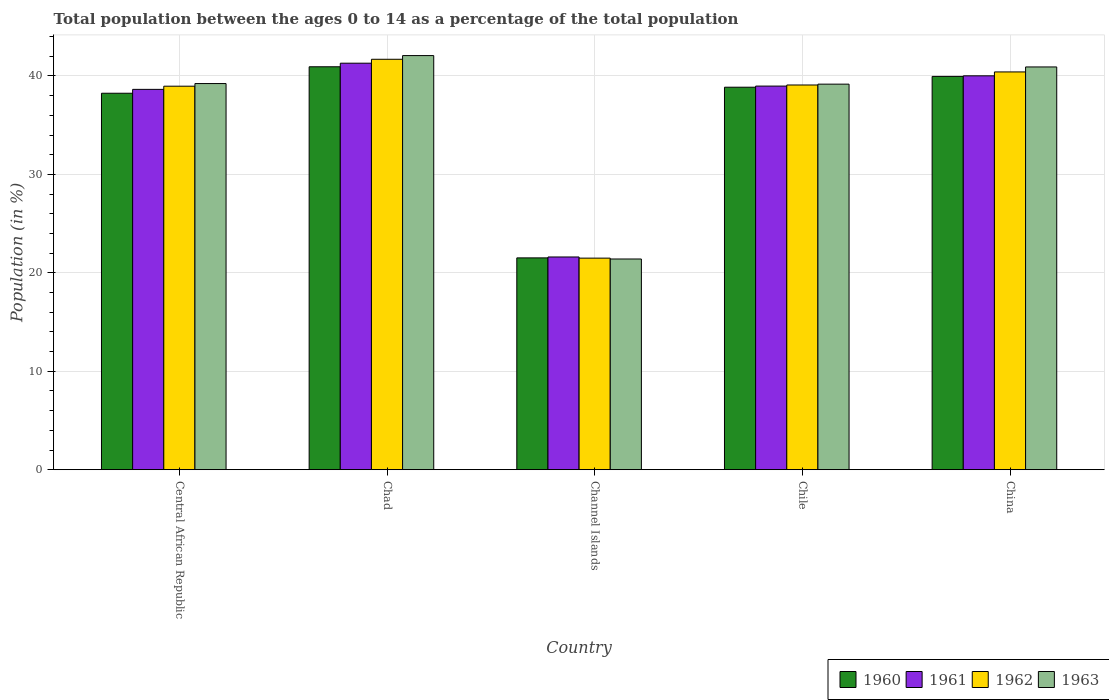Are the number of bars per tick equal to the number of legend labels?
Ensure brevity in your answer.  Yes. Are the number of bars on each tick of the X-axis equal?
Offer a terse response. Yes. How many bars are there on the 1st tick from the right?
Offer a very short reply. 4. What is the label of the 5th group of bars from the left?
Make the answer very short. China. What is the percentage of the population ages 0 to 14 in 1960 in Chile?
Keep it short and to the point. 38.86. Across all countries, what is the maximum percentage of the population ages 0 to 14 in 1962?
Ensure brevity in your answer.  41.7. Across all countries, what is the minimum percentage of the population ages 0 to 14 in 1962?
Your answer should be very brief. 21.49. In which country was the percentage of the population ages 0 to 14 in 1963 maximum?
Your answer should be compact. Chad. In which country was the percentage of the population ages 0 to 14 in 1963 minimum?
Your answer should be very brief. Channel Islands. What is the total percentage of the population ages 0 to 14 in 1961 in the graph?
Your answer should be compact. 180.53. What is the difference between the percentage of the population ages 0 to 14 in 1962 in Channel Islands and that in China?
Make the answer very short. -18.92. What is the difference between the percentage of the population ages 0 to 14 in 1962 in China and the percentage of the population ages 0 to 14 in 1963 in Channel Islands?
Ensure brevity in your answer.  19. What is the average percentage of the population ages 0 to 14 in 1962 per country?
Provide a short and direct response. 36.33. What is the difference between the percentage of the population ages 0 to 14 of/in 1963 and percentage of the population ages 0 to 14 of/in 1962 in Central African Republic?
Your answer should be very brief. 0.27. What is the ratio of the percentage of the population ages 0 to 14 in 1962 in Central African Republic to that in Chad?
Provide a succinct answer. 0.93. Is the difference between the percentage of the population ages 0 to 14 in 1963 in Chad and China greater than the difference between the percentage of the population ages 0 to 14 in 1962 in Chad and China?
Make the answer very short. No. What is the difference between the highest and the second highest percentage of the population ages 0 to 14 in 1960?
Provide a succinct answer. 2.08. What is the difference between the highest and the lowest percentage of the population ages 0 to 14 in 1960?
Your response must be concise. 19.41. Is the sum of the percentage of the population ages 0 to 14 in 1962 in Chad and Channel Islands greater than the maximum percentage of the population ages 0 to 14 in 1961 across all countries?
Offer a terse response. Yes. Is it the case that in every country, the sum of the percentage of the population ages 0 to 14 in 1962 and percentage of the population ages 0 to 14 in 1963 is greater than the percentage of the population ages 0 to 14 in 1961?
Your response must be concise. Yes. How many bars are there?
Offer a terse response. 20. Are all the bars in the graph horizontal?
Ensure brevity in your answer.  No. How many countries are there in the graph?
Your answer should be very brief. 5. What is the difference between two consecutive major ticks on the Y-axis?
Keep it short and to the point. 10. Does the graph contain grids?
Your answer should be compact. Yes. How are the legend labels stacked?
Offer a terse response. Horizontal. What is the title of the graph?
Your answer should be compact. Total population between the ages 0 to 14 as a percentage of the total population. Does "2008" appear as one of the legend labels in the graph?
Give a very brief answer. No. What is the label or title of the Y-axis?
Provide a short and direct response. Population (in %). What is the Population (in %) in 1960 in Central African Republic?
Your response must be concise. 38.24. What is the Population (in %) of 1961 in Central African Republic?
Your response must be concise. 38.64. What is the Population (in %) in 1962 in Central African Republic?
Offer a very short reply. 38.96. What is the Population (in %) in 1963 in Central African Republic?
Make the answer very short. 39.23. What is the Population (in %) of 1960 in Chad?
Offer a terse response. 40.93. What is the Population (in %) of 1961 in Chad?
Make the answer very short. 41.3. What is the Population (in %) of 1962 in Chad?
Make the answer very short. 41.7. What is the Population (in %) of 1963 in Chad?
Offer a very short reply. 42.07. What is the Population (in %) of 1960 in Channel Islands?
Keep it short and to the point. 21.52. What is the Population (in %) of 1961 in Channel Islands?
Provide a short and direct response. 21.61. What is the Population (in %) of 1962 in Channel Islands?
Ensure brevity in your answer.  21.49. What is the Population (in %) of 1963 in Channel Islands?
Provide a short and direct response. 21.41. What is the Population (in %) of 1960 in Chile?
Offer a very short reply. 38.86. What is the Population (in %) of 1961 in Chile?
Give a very brief answer. 38.97. What is the Population (in %) in 1962 in Chile?
Your answer should be very brief. 39.08. What is the Population (in %) in 1963 in Chile?
Your answer should be very brief. 39.17. What is the Population (in %) of 1960 in China?
Give a very brief answer. 39.96. What is the Population (in %) in 1961 in China?
Offer a very short reply. 40.01. What is the Population (in %) of 1962 in China?
Your response must be concise. 40.41. What is the Population (in %) of 1963 in China?
Your response must be concise. 40.92. Across all countries, what is the maximum Population (in %) of 1960?
Offer a terse response. 40.93. Across all countries, what is the maximum Population (in %) of 1961?
Provide a short and direct response. 41.3. Across all countries, what is the maximum Population (in %) in 1962?
Provide a short and direct response. 41.7. Across all countries, what is the maximum Population (in %) in 1963?
Your response must be concise. 42.07. Across all countries, what is the minimum Population (in %) of 1960?
Offer a very short reply. 21.52. Across all countries, what is the minimum Population (in %) of 1961?
Give a very brief answer. 21.61. Across all countries, what is the minimum Population (in %) of 1962?
Make the answer very short. 21.49. Across all countries, what is the minimum Population (in %) in 1963?
Provide a succinct answer. 21.41. What is the total Population (in %) in 1960 in the graph?
Your answer should be compact. 179.51. What is the total Population (in %) in 1961 in the graph?
Offer a very short reply. 180.53. What is the total Population (in %) in 1962 in the graph?
Offer a very short reply. 181.64. What is the total Population (in %) of 1963 in the graph?
Ensure brevity in your answer.  182.79. What is the difference between the Population (in %) of 1960 in Central African Republic and that in Chad?
Provide a succinct answer. -2.69. What is the difference between the Population (in %) of 1961 in Central African Republic and that in Chad?
Offer a very short reply. -2.66. What is the difference between the Population (in %) of 1962 in Central African Republic and that in Chad?
Provide a succinct answer. -2.73. What is the difference between the Population (in %) of 1963 in Central African Republic and that in Chad?
Give a very brief answer. -2.84. What is the difference between the Population (in %) of 1960 in Central African Republic and that in Channel Islands?
Offer a terse response. 16.73. What is the difference between the Population (in %) of 1961 in Central African Republic and that in Channel Islands?
Offer a very short reply. 17.03. What is the difference between the Population (in %) of 1962 in Central African Republic and that in Channel Islands?
Keep it short and to the point. 17.47. What is the difference between the Population (in %) of 1963 in Central African Republic and that in Channel Islands?
Your answer should be very brief. 17.82. What is the difference between the Population (in %) in 1960 in Central African Republic and that in Chile?
Give a very brief answer. -0.61. What is the difference between the Population (in %) of 1961 in Central African Republic and that in Chile?
Make the answer very short. -0.33. What is the difference between the Population (in %) of 1962 in Central African Republic and that in Chile?
Offer a very short reply. -0.12. What is the difference between the Population (in %) in 1963 in Central African Republic and that in Chile?
Provide a succinct answer. 0.06. What is the difference between the Population (in %) of 1960 in Central African Republic and that in China?
Your answer should be compact. -1.71. What is the difference between the Population (in %) of 1961 in Central African Republic and that in China?
Offer a very short reply. -1.38. What is the difference between the Population (in %) in 1962 in Central African Republic and that in China?
Offer a very short reply. -1.45. What is the difference between the Population (in %) in 1963 in Central African Republic and that in China?
Offer a very short reply. -1.69. What is the difference between the Population (in %) of 1960 in Chad and that in Channel Islands?
Offer a terse response. 19.41. What is the difference between the Population (in %) of 1961 in Chad and that in Channel Islands?
Offer a very short reply. 19.69. What is the difference between the Population (in %) in 1962 in Chad and that in Channel Islands?
Provide a short and direct response. 20.2. What is the difference between the Population (in %) in 1963 in Chad and that in Channel Islands?
Offer a terse response. 20.67. What is the difference between the Population (in %) of 1960 in Chad and that in Chile?
Give a very brief answer. 2.08. What is the difference between the Population (in %) in 1961 in Chad and that in Chile?
Offer a terse response. 2.33. What is the difference between the Population (in %) in 1962 in Chad and that in Chile?
Your response must be concise. 2.61. What is the difference between the Population (in %) in 1963 in Chad and that in Chile?
Your answer should be compact. 2.9. What is the difference between the Population (in %) of 1960 in Chad and that in China?
Your response must be concise. 0.98. What is the difference between the Population (in %) in 1961 in Chad and that in China?
Provide a short and direct response. 1.28. What is the difference between the Population (in %) in 1962 in Chad and that in China?
Provide a succinct answer. 1.29. What is the difference between the Population (in %) of 1963 in Chad and that in China?
Give a very brief answer. 1.15. What is the difference between the Population (in %) of 1960 in Channel Islands and that in Chile?
Give a very brief answer. -17.34. What is the difference between the Population (in %) in 1961 in Channel Islands and that in Chile?
Provide a short and direct response. -17.36. What is the difference between the Population (in %) in 1962 in Channel Islands and that in Chile?
Provide a short and direct response. -17.59. What is the difference between the Population (in %) of 1963 in Channel Islands and that in Chile?
Ensure brevity in your answer.  -17.76. What is the difference between the Population (in %) in 1960 in Channel Islands and that in China?
Your answer should be very brief. -18.44. What is the difference between the Population (in %) in 1961 in Channel Islands and that in China?
Make the answer very short. -18.4. What is the difference between the Population (in %) of 1962 in Channel Islands and that in China?
Provide a succinct answer. -18.92. What is the difference between the Population (in %) in 1963 in Channel Islands and that in China?
Offer a terse response. -19.51. What is the difference between the Population (in %) in 1960 in Chile and that in China?
Provide a succinct answer. -1.1. What is the difference between the Population (in %) of 1961 in Chile and that in China?
Give a very brief answer. -1.04. What is the difference between the Population (in %) of 1962 in Chile and that in China?
Give a very brief answer. -1.33. What is the difference between the Population (in %) in 1963 in Chile and that in China?
Ensure brevity in your answer.  -1.75. What is the difference between the Population (in %) of 1960 in Central African Republic and the Population (in %) of 1961 in Chad?
Your answer should be compact. -3.05. What is the difference between the Population (in %) in 1960 in Central African Republic and the Population (in %) in 1962 in Chad?
Your answer should be very brief. -3.45. What is the difference between the Population (in %) of 1960 in Central African Republic and the Population (in %) of 1963 in Chad?
Your answer should be compact. -3.83. What is the difference between the Population (in %) of 1961 in Central African Republic and the Population (in %) of 1962 in Chad?
Provide a short and direct response. -3.06. What is the difference between the Population (in %) of 1961 in Central African Republic and the Population (in %) of 1963 in Chad?
Keep it short and to the point. -3.43. What is the difference between the Population (in %) of 1962 in Central African Republic and the Population (in %) of 1963 in Chad?
Your answer should be very brief. -3.11. What is the difference between the Population (in %) of 1960 in Central African Republic and the Population (in %) of 1961 in Channel Islands?
Provide a succinct answer. 16.63. What is the difference between the Population (in %) of 1960 in Central African Republic and the Population (in %) of 1962 in Channel Islands?
Keep it short and to the point. 16.75. What is the difference between the Population (in %) of 1960 in Central African Republic and the Population (in %) of 1963 in Channel Islands?
Provide a short and direct response. 16.84. What is the difference between the Population (in %) of 1961 in Central African Republic and the Population (in %) of 1962 in Channel Islands?
Give a very brief answer. 17.15. What is the difference between the Population (in %) in 1961 in Central African Republic and the Population (in %) in 1963 in Channel Islands?
Keep it short and to the point. 17.23. What is the difference between the Population (in %) of 1962 in Central African Republic and the Population (in %) of 1963 in Channel Islands?
Give a very brief answer. 17.56. What is the difference between the Population (in %) in 1960 in Central African Republic and the Population (in %) in 1961 in Chile?
Make the answer very short. -0.73. What is the difference between the Population (in %) in 1960 in Central African Republic and the Population (in %) in 1962 in Chile?
Your response must be concise. -0.84. What is the difference between the Population (in %) in 1960 in Central African Republic and the Population (in %) in 1963 in Chile?
Your answer should be very brief. -0.92. What is the difference between the Population (in %) in 1961 in Central African Republic and the Population (in %) in 1962 in Chile?
Give a very brief answer. -0.44. What is the difference between the Population (in %) in 1961 in Central African Republic and the Population (in %) in 1963 in Chile?
Your answer should be very brief. -0.53. What is the difference between the Population (in %) of 1962 in Central African Republic and the Population (in %) of 1963 in Chile?
Provide a short and direct response. -0.21. What is the difference between the Population (in %) in 1960 in Central African Republic and the Population (in %) in 1961 in China?
Offer a terse response. -1.77. What is the difference between the Population (in %) in 1960 in Central African Republic and the Population (in %) in 1962 in China?
Your answer should be compact. -2.17. What is the difference between the Population (in %) of 1960 in Central African Republic and the Population (in %) of 1963 in China?
Offer a terse response. -2.67. What is the difference between the Population (in %) in 1961 in Central African Republic and the Population (in %) in 1962 in China?
Provide a succinct answer. -1.77. What is the difference between the Population (in %) in 1961 in Central African Republic and the Population (in %) in 1963 in China?
Keep it short and to the point. -2.28. What is the difference between the Population (in %) in 1962 in Central African Republic and the Population (in %) in 1963 in China?
Provide a succinct answer. -1.96. What is the difference between the Population (in %) in 1960 in Chad and the Population (in %) in 1961 in Channel Islands?
Make the answer very short. 19.32. What is the difference between the Population (in %) of 1960 in Chad and the Population (in %) of 1962 in Channel Islands?
Give a very brief answer. 19.44. What is the difference between the Population (in %) of 1960 in Chad and the Population (in %) of 1963 in Channel Islands?
Your answer should be compact. 19.53. What is the difference between the Population (in %) of 1961 in Chad and the Population (in %) of 1962 in Channel Islands?
Provide a succinct answer. 19.8. What is the difference between the Population (in %) of 1961 in Chad and the Population (in %) of 1963 in Channel Islands?
Your response must be concise. 19.89. What is the difference between the Population (in %) of 1962 in Chad and the Population (in %) of 1963 in Channel Islands?
Offer a very short reply. 20.29. What is the difference between the Population (in %) in 1960 in Chad and the Population (in %) in 1961 in Chile?
Keep it short and to the point. 1.96. What is the difference between the Population (in %) of 1960 in Chad and the Population (in %) of 1962 in Chile?
Provide a short and direct response. 1.85. What is the difference between the Population (in %) of 1960 in Chad and the Population (in %) of 1963 in Chile?
Make the answer very short. 1.76. What is the difference between the Population (in %) of 1961 in Chad and the Population (in %) of 1962 in Chile?
Provide a short and direct response. 2.22. What is the difference between the Population (in %) in 1961 in Chad and the Population (in %) in 1963 in Chile?
Give a very brief answer. 2.13. What is the difference between the Population (in %) in 1962 in Chad and the Population (in %) in 1963 in Chile?
Ensure brevity in your answer.  2.53. What is the difference between the Population (in %) of 1960 in Chad and the Population (in %) of 1961 in China?
Your answer should be very brief. 0.92. What is the difference between the Population (in %) in 1960 in Chad and the Population (in %) in 1962 in China?
Offer a very short reply. 0.52. What is the difference between the Population (in %) of 1960 in Chad and the Population (in %) of 1963 in China?
Your response must be concise. 0.02. What is the difference between the Population (in %) of 1961 in Chad and the Population (in %) of 1962 in China?
Provide a short and direct response. 0.89. What is the difference between the Population (in %) of 1961 in Chad and the Population (in %) of 1963 in China?
Keep it short and to the point. 0.38. What is the difference between the Population (in %) in 1962 in Chad and the Population (in %) in 1963 in China?
Give a very brief answer. 0.78. What is the difference between the Population (in %) in 1960 in Channel Islands and the Population (in %) in 1961 in Chile?
Your response must be concise. -17.45. What is the difference between the Population (in %) in 1960 in Channel Islands and the Population (in %) in 1962 in Chile?
Offer a terse response. -17.56. What is the difference between the Population (in %) of 1960 in Channel Islands and the Population (in %) of 1963 in Chile?
Provide a short and direct response. -17.65. What is the difference between the Population (in %) in 1961 in Channel Islands and the Population (in %) in 1962 in Chile?
Make the answer very short. -17.47. What is the difference between the Population (in %) of 1961 in Channel Islands and the Population (in %) of 1963 in Chile?
Offer a terse response. -17.56. What is the difference between the Population (in %) in 1962 in Channel Islands and the Population (in %) in 1963 in Chile?
Keep it short and to the point. -17.68. What is the difference between the Population (in %) of 1960 in Channel Islands and the Population (in %) of 1961 in China?
Your answer should be compact. -18.5. What is the difference between the Population (in %) in 1960 in Channel Islands and the Population (in %) in 1962 in China?
Your answer should be compact. -18.89. What is the difference between the Population (in %) in 1960 in Channel Islands and the Population (in %) in 1963 in China?
Ensure brevity in your answer.  -19.4. What is the difference between the Population (in %) in 1961 in Channel Islands and the Population (in %) in 1962 in China?
Offer a very short reply. -18.8. What is the difference between the Population (in %) of 1961 in Channel Islands and the Population (in %) of 1963 in China?
Make the answer very short. -19.31. What is the difference between the Population (in %) in 1962 in Channel Islands and the Population (in %) in 1963 in China?
Keep it short and to the point. -19.42. What is the difference between the Population (in %) in 1960 in Chile and the Population (in %) in 1961 in China?
Provide a succinct answer. -1.16. What is the difference between the Population (in %) of 1960 in Chile and the Population (in %) of 1962 in China?
Your answer should be very brief. -1.55. What is the difference between the Population (in %) of 1960 in Chile and the Population (in %) of 1963 in China?
Make the answer very short. -2.06. What is the difference between the Population (in %) in 1961 in Chile and the Population (in %) in 1962 in China?
Give a very brief answer. -1.44. What is the difference between the Population (in %) in 1961 in Chile and the Population (in %) in 1963 in China?
Provide a short and direct response. -1.95. What is the difference between the Population (in %) of 1962 in Chile and the Population (in %) of 1963 in China?
Make the answer very short. -1.83. What is the average Population (in %) of 1960 per country?
Your response must be concise. 35.9. What is the average Population (in %) in 1961 per country?
Your response must be concise. 36.11. What is the average Population (in %) of 1962 per country?
Keep it short and to the point. 36.33. What is the average Population (in %) in 1963 per country?
Your response must be concise. 36.56. What is the difference between the Population (in %) in 1960 and Population (in %) in 1961 in Central African Republic?
Provide a succinct answer. -0.39. What is the difference between the Population (in %) in 1960 and Population (in %) in 1962 in Central African Republic?
Your answer should be very brief. -0.72. What is the difference between the Population (in %) in 1960 and Population (in %) in 1963 in Central African Republic?
Your answer should be compact. -0.98. What is the difference between the Population (in %) of 1961 and Population (in %) of 1962 in Central African Republic?
Offer a very short reply. -0.32. What is the difference between the Population (in %) in 1961 and Population (in %) in 1963 in Central African Republic?
Make the answer very short. -0.59. What is the difference between the Population (in %) of 1962 and Population (in %) of 1963 in Central African Republic?
Your answer should be compact. -0.27. What is the difference between the Population (in %) in 1960 and Population (in %) in 1961 in Chad?
Make the answer very short. -0.36. What is the difference between the Population (in %) in 1960 and Population (in %) in 1962 in Chad?
Your response must be concise. -0.76. What is the difference between the Population (in %) of 1960 and Population (in %) of 1963 in Chad?
Make the answer very short. -1.14. What is the difference between the Population (in %) of 1961 and Population (in %) of 1962 in Chad?
Your answer should be compact. -0.4. What is the difference between the Population (in %) of 1961 and Population (in %) of 1963 in Chad?
Offer a terse response. -0.77. What is the difference between the Population (in %) in 1962 and Population (in %) in 1963 in Chad?
Your answer should be very brief. -0.38. What is the difference between the Population (in %) in 1960 and Population (in %) in 1961 in Channel Islands?
Offer a terse response. -0.09. What is the difference between the Population (in %) of 1960 and Population (in %) of 1962 in Channel Islands?
Provide a succinct answer. 0.03. What is the difference between the Population (in %) in 1960 and Population (in %) in 1963 in Channel Islands?
Offer a very short reply. 0.11. What is the difference between the Population (in %) of 1961 and Population (in %) of 1962 in Channel Islands?
Provide a succinct answer. 0.12. What is the difference between the Population (in %) in 1961 and Population (in %) in 1963 in Channel Islands?
Provide a succinct answer. 0.2. What is the difference between the Population (in %) in 1962 and Population (in %) in 1963 in Channel Islands?
Offer a terse response. 0.09. What is the difference between the Population (in %) of 1960 and Population (in %) of 1961 in Chile?
Ensure brevity in your answer.  -0.11. What is the difference between the Population (in %) in 1960 and Population (in %) in 1962 in Chile?
Provide a short and direct response. -0.22. What is the difference between the Population (in %) in 1960 and Population (in %) in 1963 in Chile?
Offer a terse response. -0.31. What is the difference between the Population (in %) in 1961 and Population (in %) in 1962 in Chile?
Ensure brevity in your answer.  -0.11. What is the difference between the Population (in %) in 1961 and Population (in %) in 1963 in Chile?
Your answer should be very brief. -0.2. What is the difference between the Population (in %) in 1962 and Population (in %) in 1963 in Chile?
Provide a short and direct response. -0.09. What is the difference between the Population (in %) in 1960 and Population (in %) in 1961 in China?
Your response must be concise. -0.06. What is the difference between the Population (in %) in 1960 and Population (in %) in 1962 in China?
Give a very brief answer. -0.45. What is the difference between the Population (in %) in 1960 and Population (in %) in 1963 in China?
Your response must be concise. -0.96. What is the difference between the Population (in %) of 1961 and Population (in %) of 1962 in China?
Your response must be concise. -0.4. What is the difference between the Population (in %) of 1961 and Population (in %) of 1963 in China?
Keep it short and to the point. -0.9. What is the difference between the Population (in %) in 1962 and Population (in %) in 1963 in China?
Provide a succinct answer. -0.51. What is the ratio of the Population (in %) of 1960 in Central African Republic to that in Chad?
Offer a very short reply. 0.93. What is the ratio of the Population (in %) in 1961 in Central African Republic to that in Chad?
Make the answer very short. 0.94. What is the ratio of the Population (in %) in 1962 in Central African Republic to that in Chad?
Provide a short and direct response. 0.93. What is the ratio of the Population (in %) in 1963 in Central African Republic to that in Chad?
Offer a very short reply. 0.93. What is the ratio of the Population (in %) in 1960 in Central African Republic to that in Channel Islands?
Keep it short and to the point. 1.78. What is the ratio of the Population (in %) of 1961 in Central African Republic to that in Channel Islands?
Provide a succinct answer. 1.79. What is the ratio of the Population (in %) of 1962 in Central African Republic to that in Channel Islands?
Offer a very short reply. 1.81. What is the ratio of the Population (in %) of 1963 in Central African Republic to that in Channel Islands?
Keep it short and to the point. 1.83. What is the ratio of the Population (in %) of 1960 in Central African Republic to that in Chile?
Your answer should be very brief. 0.98. What is the ratio of the Population (in %) in 1961 in Central African Republic to that in Chile?
Provide a succinct answer. 0.99. What is the ratio of the Population (in %) in 1962 in Central African Republic to that in Chile?
Your response must be concise. 1. What is the ratio of the Population (in %) of 1960 in Central African Republic to that in China?
Provide a short and direct response. 0.96. What is the ratio of the Population (in %) in 1961 in Central African Republic to that in China?
Make the answer very short. 0.97. What is the ratio of the Population (in %) in 1962 in Central African Republic to that in China?
Ensure brevity in your answer.  0.96. What is the ratio of the Population (in %) of 1963 in Central African Republic to that in China?
Your answer should be compact. 0.96. What is the ratio of the Population (in %) in 1960 in Chad to that in Channel Islands?
Your answer should be compact. 1.9. What is the ratio of the Population (in %) of 1961 in Chad to that in Channel Islands?
Ensure brevity in your answer.  1.91. What is the ratio of the Population (in %) in 1962 in Chad to that in Channel Islands?
Your answer should be compact. 1.94. What is the ratio of the Population (in %) in 1963 in Chad to that in Channel Islands?
Give a very brief answer. 1.97. What is the ratio of the Population (in %) in 1960 in Chad to that in Chile?
Give a very brief answer. 1.05. What is the ratio of the Population (in %) in 1961 in Chad to that in Chile?
Offer a terse response. 1.06. What is the ratio of the Population (in %) in 1962 in Chad to that in Chile?
Keep it short and to the point. 1.07. What is the ratio of the Population (in %) in 1963 in Chad to that in Chile?
Your response must be concise. 1.07. What is the ratio of the Population (in %) of 1960 in Chad to that in China?
Your answer should be very brief. 1.02. What is the ratio of the Population (in %) of 1961 in Chad to that in China?
Provide a short and direct response. 1.03. What is the ratio of the Population (in %) of 1962 in Chad to that in China?
Ensure brevity in your answer.  1.03. What is the ratio of the Population (in %) of 1963 in Chad to that in China?
Your answer should be compact. 1.03. What is the ratio of the Population (in %) of 1960 in Channel Islands to that in Chile?
Provide a short and direct response. 0.55. What is the ratio of the Population (in %) of 1961 in Channel Islands to that in Chile?
Provide a succinct answer. 0.55. What is the ratio of the Population (in %) of 1962 in Channel Islands to that in Chile?
Make the answer very short. 0.55. What is the ratio of the Population (in %) of 1963 in Channel Islands to that in Chile?
Ensure brevity in your answer.  0.55. What is the ratio of the Population (in %) in 1960 in Channel Islands to that in China?
Your response must be concise. 0.54. What is the ratio of the Population (in %) in 1961 in Channel Islands to that in China?
Keep it short and to the point. 0.54. What is the ratio of the Population (in %) of 1962 in Channel Islands to that in China?
Your response must be concise. 0.53. What is the ratio of the Population (in %) of 1963 in Channel Islands to that in China?
Give a very brief answer. 0.52. What is the ratio of the Population (in %) in 1960 in Chile to that in China?
Offer a very short reply. 0.97. What is the ratio of the Population (in %) of 1961 in Chile to that in China?
Your answer should be very brief. 0.97. What is the ratio of the Population (in %) of 1962 in Chile to that in China?
Give a very brief answer. 0.97. What is the ratio of the Population (in %) of 1963 in Chile to that in China?
Provide a succinct answer. 0.96. What is the difference between the highest and the second highest Population (in %) of 1960?
Your response must be concise. 0.98. What is the difference between the highest and the second highest Population (in %) in 1961?
Offer a very short reply. 1.28. What is the difference between the highest and the second highest Population (in %) of 1962?
Provide a succinct answer. 1.29. What is the difference between the highest and the second highest Population (in %) of 1963?
Keep it short and to the point. 1.15. What is the difference between the highest and the lowest Population (in %) of 1960?
Provide a short and direct response. 19.41. What is the difference between the highest and the lowest Population (in %) in 1961?
Give a very brief answer. 19.69. What is the difference between the highest and the lowest Population (in %) in 1962?
Give a very brief answer. 20.2. What is the difference between the highest and the lowest Population (in %) in 1963?
Keep it short and to the point. 20.67. 